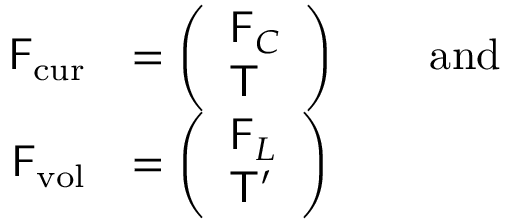<formula> <loc_0><loc_0><loc_500><loc_500>\begin{array} { r l } { F _ { c u r } } & { = \left ( \begin{array} { l } { F _ { C } } \\ { T } \end{array} \right ) \quad a n d } \\ { F _ { v o l } } & { = \left ( \begin{array} { l } { F _ { L } } \\ { T ^ { \prime } } \end{array} \right ) } \end{array}</formula> 